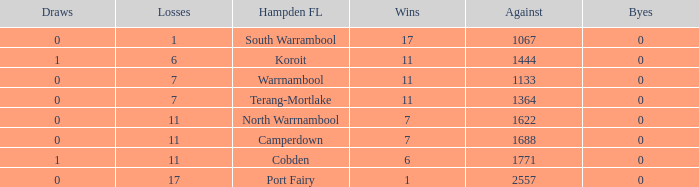What were the losses when the byes were less than 0? None. 